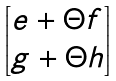Convert formula to latex. <formula><loc_0><loc_0><loc_500><loc_500>\begin{bmatrix} e + \Theta f \\ g + \Theta h \\ \end{bmatrix}</formula> 